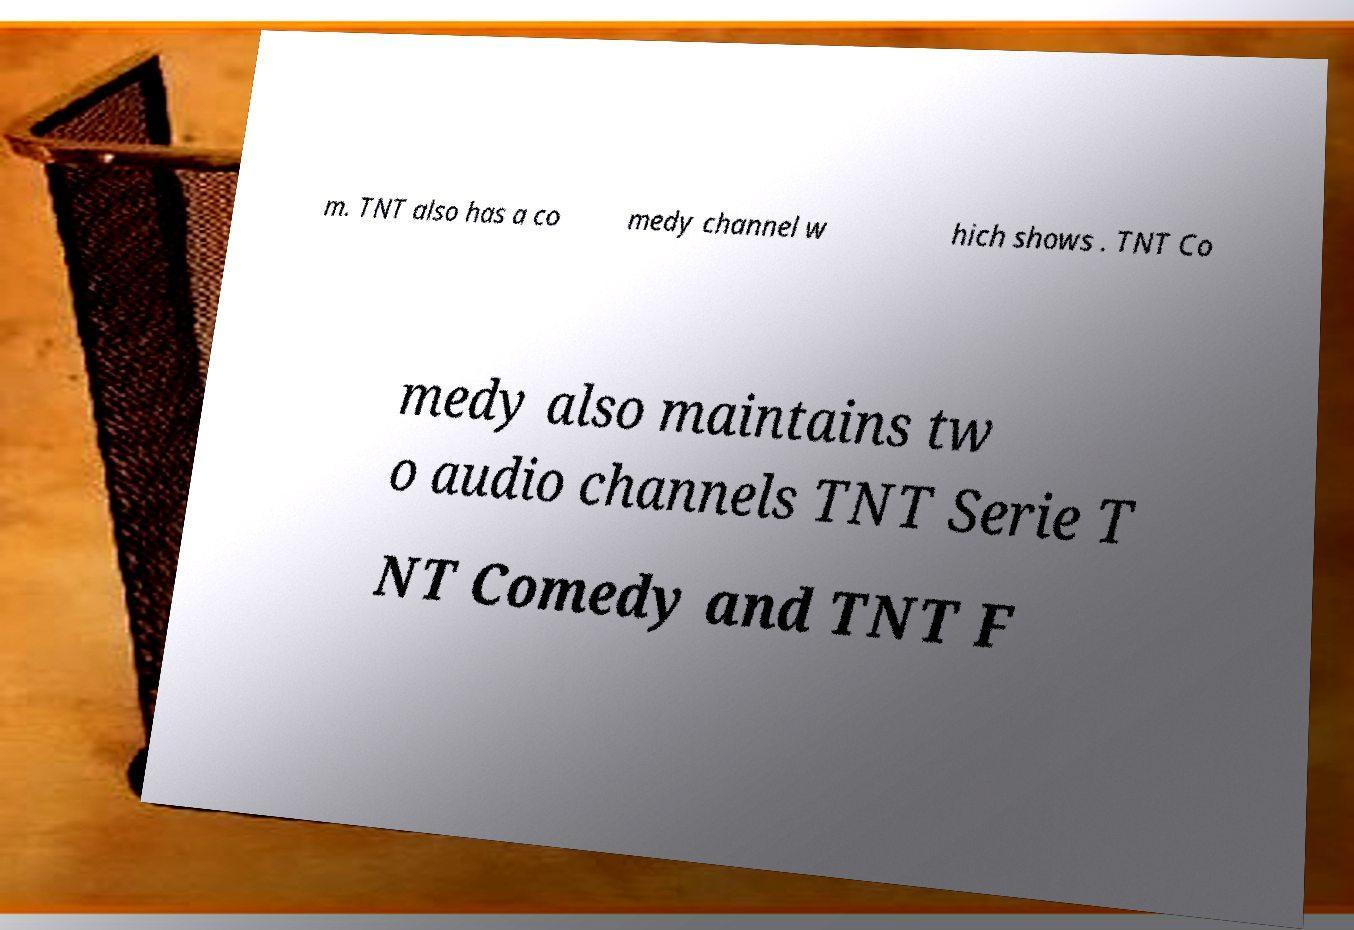What messages or text are displayed in this image? I need them in a readable, typed format. m. TNT also has a co medy channel w hich shows . TNT Co medy also maintains tw o audio channels TNT Serie T NT Comedy and TNT F 